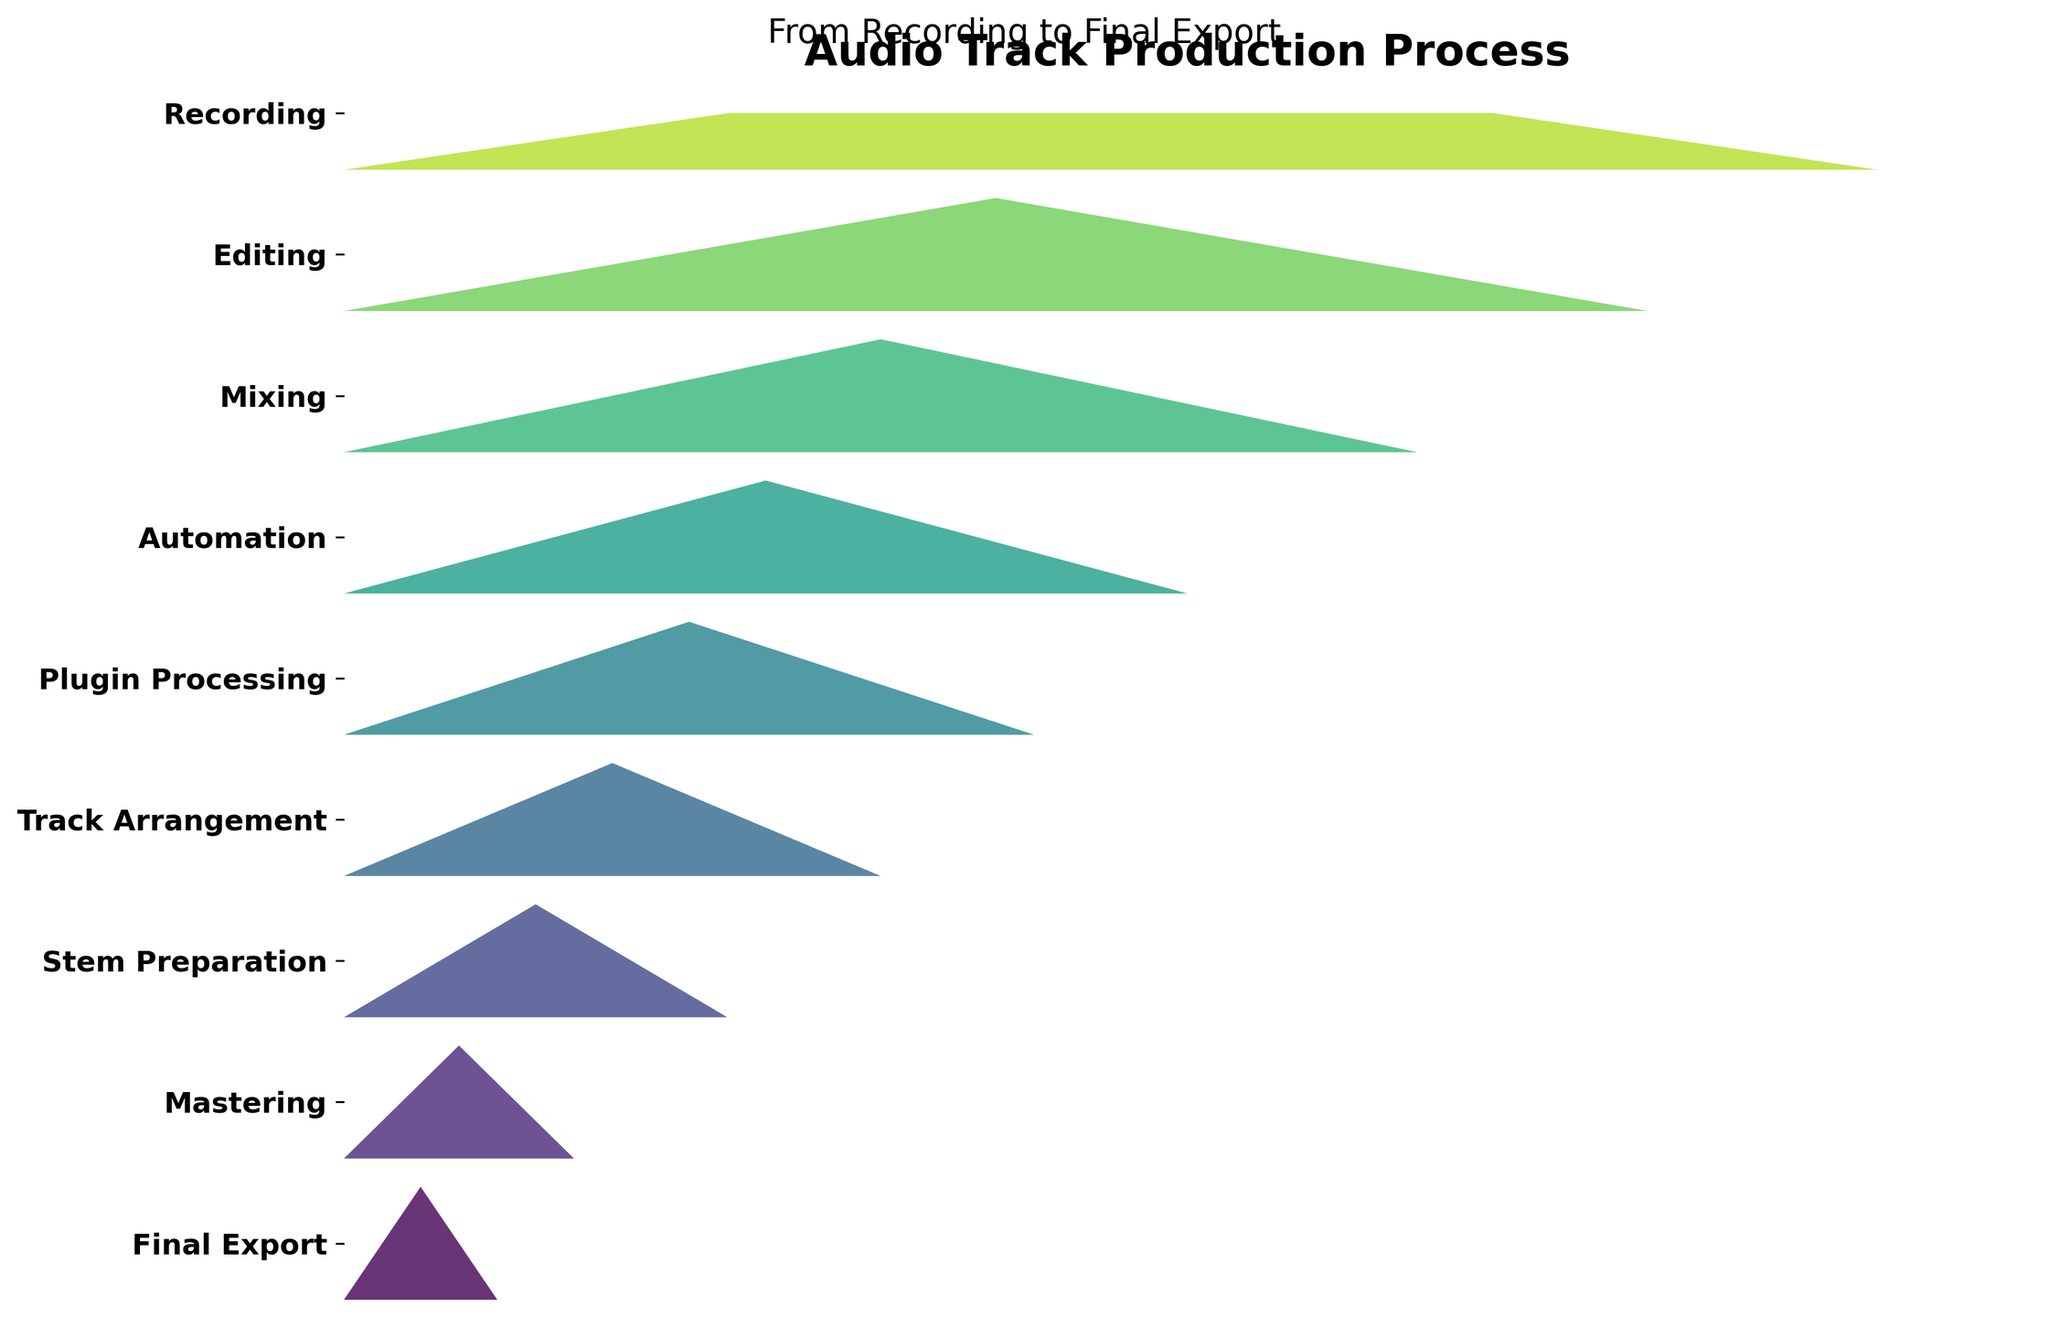What's the title of the figure? Look at the text at the top of the figure; it provides the title.
Answer: Audio Track Production Process What is the first step in the audio track production process? The steps are listed from bottom to top; the first step at the bottom is the initial step.
Answer: Recording Which step has the lowest percentage? Examine the percentages listed next to each step; the lowest percentage corresponds to the final step.
Answer: Final Export What's the difference in percentage between Mixing and Automation? Find the percentage for Mixing (70%) and Automation (55%), and subtract the latter from the former. 70 - 55 = 15
Answer: 15% Is the percentage for Plugin Processing less than for Automation? Compare the percentages for Plugin Processing (45%) and Automation (55%); since 45 is less than 55, the answer is yes.
Answer: Yes How many steps are there in the audio track production process? Count the total number of unique steps listed in the funnel chart.
Answer: 9 Which step follows Editing in the audio production process? Look at the step listed right before Editing moving upward in the funnel chart.
Answer: Mixing What is the sum of percentages for Track Arrangement and Stem Preparation? Add the percentages for Track Arrangement (35%) and Stem Preparation (25%). 35 + 25 = 60
Answer: 60% Between which two steps is there the largest drop in percentage? Calculate the percentage differences between each consecutive step and identify the largest drop. The largest drop is between Recording (100%) and Editing (85%). 100 - 85 = 15
Answer: Recording and Editing What percentage of the process is completed by the time you reach Automation? Look at all the steps up to and including Automation, then take the last percentage listed for Automation (55%).
Answer: 55% 